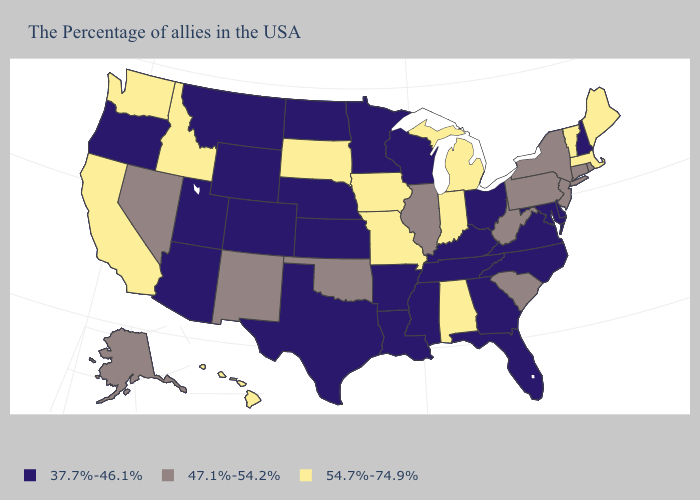What is the highest value in the Northeast ?
Quick response, please. 54.7%-74.9%. What is the lowest value in the USA?
Quick response, please. 37.7%-46.1%. What is the lowest value in states that border Georgia?
Quick response, please. 37.7%-46.1%. Name the states that have a value in the range 37.7%-46.1%?
Answer briefly. New Hampshire, Delaware, Maryland, Virginia, North Carolina, Ohio, Florida, Georgia, Kentucky, Tennessee, Wisconsin, Mississippi, Louisiana, Arkansas, Minnesota, Kansas, Nebraska, Texas, North Dakota, Wyoming, Colorado, Utah, Montana, Arizona, Oregon. Name the states that have a value in the range 37.7%-46.1%?
Concise answer only. New Hampshire, Delaware, Maryland, Virginia, North Carolina, Ohio, Florida, Georgia, Kentucky, Tennessee, Wisconsin, Mississippi, Louisiana, Arkansas, Minnesota, Kansas, Nebraska, Texas, North Dakota, Wyoming, Colorado, Utah, Montana, Arizona, Oregon. Name the states that have a value in the range 37.7%-46.1%?
Keep it brief. New Hampshire, Delaware, Maryland, Virginia, North Carolina, Ohio, Florida, Georgia, Kentucky, Tennessee, Wisconsin, Mississippi, Louisiana, Arkansas, Minnesota, Kansas, Nebraska, Texas, North Dakota, Wyoming, Colorado, Utah, Montana, Arizona, Oregon. What is the highest value in the MidWest ?
Write a very short answer. 54.7%-74.9%. What is the value of Rhode Island?
Be succinct. 47.1%-54.2%. Does South Carolina have the lowest value in the South?
Answer briefly. No. What is the value of Connecticut?
Concise answer only. 47.1%-54.2%. Name the states that have a value in the range 37.7%-46.1%?
Be succinct. New Hampshire, Delaware, Maryland, Virginia, North Carolina, Ohio, Florida, Georgia, Kentucky, Tennessee, Wisconsin, Mississippi, Louisiana, Arkansas, Minnesota, Kansas, Nebraska, Texas, North Dakota, Wyoming, Colorado, Utah, Montana, Arizona, Oregon. What is the value of Massachusetts?
Answer briefly. 54.7%-74.9%. Name the states that have a value in the range 37.7%-46.1%?
Be succinct. New Hampshire, Delaware, Maryland, Virginia, North Carolina, Ohio, Florida, Georgia, Kentucky, Tennessee, Wisconsin, Mississippi, Louisiana, Arkansas, Minnesota, Kansas, Nebraska, Texas, North Dakota, Wyoming, Colorado, Utah, Montana, Arizona, Oregon. Among the states that border Connecticut , which have the lowest value?
Write a very short answer. Rhode Island, New York. What is the value of Utah?
Short answer required. 37.7%-46.1%. 